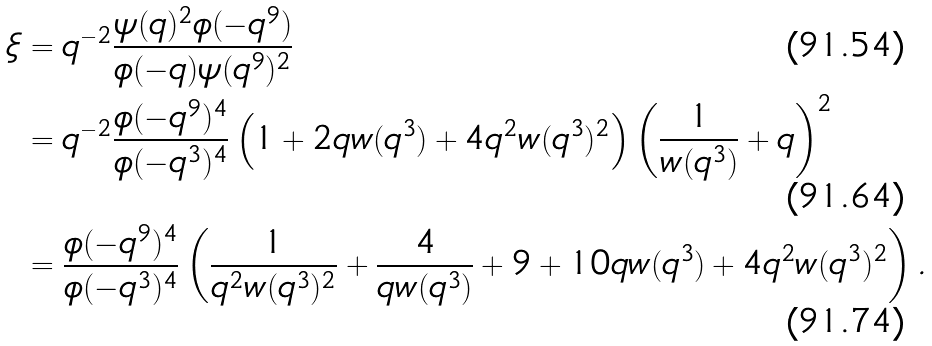Convert formula to latex. <formula><loc_0><loc_0><loc_500><loc_500>\xi & = q ^ { - 2 } \frac { \psi ( q ) ^ { 2 } \phi ( - q ^ { 9 } ) } { \phi ( - q ) \psi ( q ^ { 9 } ) ^ { 2 } } \\ & = q ^ { - 2 } \frac { \phi ( - q ^ { 9 } ) ^ { 4 } } { \phi ( - q ^ { 3 } ) ^ { 4 } } \left ( 1 + 2 q w ( q ^ { 3 } ) + 4 q ^ { 2 } w ( q ^ { 3 } ) ^ { 2 } \right ) \left ( \frac { 1 } { w ( q ^ { 3 } ) } + q \right ) ^ { 2 } \\ & = \frac { \phi ( - q ^ { 9 } ) ^ { 4 } } { \phi ( - q ^ { 3 } ) ^ { 4 } } \left ( \frac { 1 } { q ^ { 2 } w ( q ^ { 3 } ) ^ { 2 } } + \frac { 4 } { q w ( q ^ { 3 } ) } + 9 + 1 0 q w ( q ^ { 3 } ) + 4 q ^ { 2 } w ( q ^ { 3 } ) ^ { 2 } \right ) .</formula> 